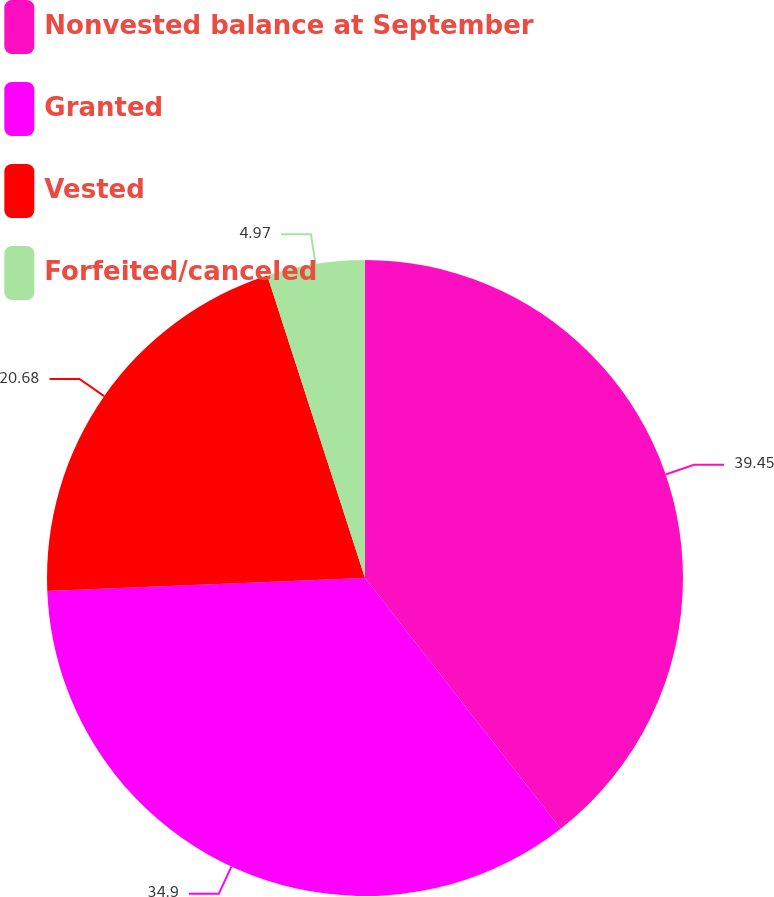<chart> <loc_0><loc_0><loc_500><loc_500><pie_chart><fcel>Nonvested balance at September<fcel>Granted<fcel>Vested<fcel>Forfeited/canceled<nl><fcel>39.45%<fcel>34.9%<fcel>20.68%<fcel>4.97%<nl></chart> 